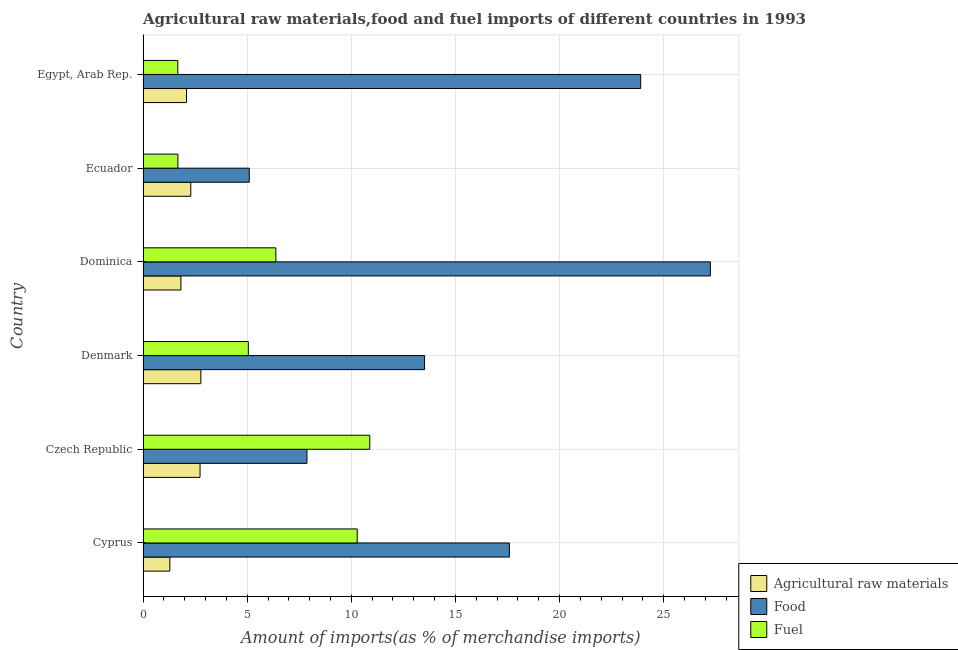How many different coloured bars are there?
Your answer should be compact. 3. How many groups of bars are there?
Ensure brevity in your answer.  6. Are the number of bars on each tick of the Y-axis equal?
Give a very brief answer. Yes. How many bars are there on the 5th tick from the top?
Your response must be concise. 3. How many bars are there on the 1st tick from the bottom?
Provide a short and direct response. 3. In how many cases, is the number of bars for a given country not equal to the number of legend labels?
Keep it short and to the point. 0. What is the percentage of fuel imports in Czech Republic?
Provide a succinct answer. 10.89. Across all countries, what is the maximum percentage of food imports?
Offer a very short reply. 27.24. Across all countries, what is the minimum percentage of fuel imports?
Ensure brevity in your answer.  1.67. In which country was the percentage of food imports maximum?
Provide a short and direct response. Dominica. In which country was the percentage of fuel imports minimum?
Your answer should be compact. Egypt, Arab Rep. What is the total percentage of raw materials imports in the graph?
Make the answer very short. 12.99. What is the difference between the percentage of fuel imports in Denmark and that in Dominica?
Offer a very short reply. -1.32. What is the difference between the percentage of food imports in Denmark and the percentage of raw materials imports in Dominica?
Give a very brief answer. 11.7. What is the average percentage of fuel imports per country?
Give a very brief answer. 5.99. What is the difference between the percentage of fuel imports and percentage of food imports in Egypt, Arab Rep.?
Your response must be concise. -22.23. In how many countries, is the percentage of raw materials imports greater than 7 %?
Make the answer very short. 0. What is the ratio of the percentage of fuel imports in Cyprus to that in Czech Republic?
Provide a short and direct response. 0.94. Is the difference between the percentage of fuel imports in Dominica and Ecuador greater than the difference between the percentage of food imports in Dominica and Ecuador?
Provide a succinct answer. No. What is the difference between the highest and the second highest percentage of fuel imports?
Your answer should be very brief. 0.6. What is the difference between the highest and the lowest percentage of fuel imports?
Provide a short and direct response. 9.22. What does the 2nd bar from the top in Ecuador represents?
Offer a terse response. Food. What does the 1st bar from the bottom in Egypt, Arab Rep. represents?
Keep it short and to the point. Agricultural raw materials. What is the difference between two consecutive major ticks on the X-axis?
Your answer should be very brief. 5. Are the values on the major ticks of X-axis written in scientific E-notation?
Offer a terse response. No. Does the graph contain any zero values?
Your response must be concise. No. Does the graph contain grids?
Your answer should be compact. Yes. Where does the legend appear in the graph?
Offer a very short reply. Bottom right. How many legend labels are there?
Ensure brevity in your answer.  3. What is the title of the graph?
Your response must be concise. Agricultural raw materials,food and fuel imports of different countries in 1993. Does "Gaseous fuel" appear as one of the legend labels in the graph?
Your answer should be very brief. No. What is the label or title of the X-axis?
Keep it short and to the point. Amount of imports(as % of merchandise imports). What is the label or title of the Y-axis?
Make the answer very short. Country. What is the Amount of imports(as % of merchandise imports) of Agricultural raw materials in Cyprus?
Provide a succinct answer. 1.29. What is the Amount of imports(as % of merchandise imports) of Food in Cyprus?
Make the answer very short. 17.59. What is the Amount of imports(as % of merchandise imports) in Fuel in Cyprus?
Your answer should be compact. 10.28. What is the Amount of imports(as % of merchandise imports) in Agricultural raw materials in Czech Republic?
Ensure brevity in your answer.  2.74. What is the Amount of imports(as % of merchandise imports) of Food in Czech Republic?
Give a very brief answer. 7.87. What is the Amount of imports(as % of merchandise imports) in Fuel in Czech Republic?
Keep it short and to the point. 10.89. What is the Amount of imports(as % of merchandise imports) in Agricultural raw materials in Denmark?
Offer a terse response. 2.78. What is the Amount of imports(as % of merchandise imports) of Food in Denmark?
Make the answer very short. 13.52. What is the Amount of imports(as % of merchandise imports) in Fuel in Denmark?
Provide a short and direct response. 5.06. What is the Amount of imports(as % of merchandise imports) of Agricultural raw materials in Dominica?
Make the answer very short. 1.82. What is the Amount of imports(as % of merchandise imports) of Food in Dominica?
Your answer should be compact. 27.24. What is the Amount of imports(as % of merchandise imports) in Fuel in Dominica?
Make the answer very short. 6.38. What is the Amount of imports(as % of merchandise imports) in Agricultural raw materials in Ecuador?
Make the answer very short. 2.29. What is the Amount of imports(as % of merchandise imports) of Food in Ecuador?
Make the answer very short. 5.1. What is the Amount of imports(as % of merchandise imports) in Fuel in Ecuador?
Your response must be concise. 1.67. What is the Amount of imports(as % of merchandise imports) in Agricultural raw materials in Egypt, Arab Rep.?
Your answer should be very brief. 2.09. What is the Amount of imports(as % of merchandise imports) in Food in Egypt, Arab Rep.?
Provide a short and direct response. 23.9. What is the Amount of imports(as % of merchandise imports) of Fuel in Egypt, Arab Rep.?
Offer a terse response. 1.67. Across all countries, what is the maximum Amount of imports(as % of merchandise imports) of Agricultural raw materials?
Your answer should be very brief. 2.78. Across all countries, what is the maximum Amount of imports(as % of merchandise imports) in Food?
Provide a succinct answer. 27.24. Across all countries, what is the maximum Amount of imports(as % of merchandise imports) in Fuel?
Provide a succinct answer. 10.89. Across all countries, what is the minimum Amount of imports(as % of merchandise imports) of Agricultural raw materials?
Provide a short and direct response. 1.29. Across all countries, what is the minimum Amount of imports(as % of merchandise imports) of Food?
Your response must be concise. 5.1. Across all countries, what is the minimum Amount of imports(as % of merchandise imports) of Fuel?
Keep it short and to the point. 1.67. What is the total Amount of imports(as % of merchandise imports) of Agricultural raw materials in the graph?
Your answer should be compact. 12.99. What is the total Amount of imports(as % of merchandise imports) of Food in the graph?
Your response must be concise. 95.22. What is the total Amount of imports(as % of merchandise imports) of Fuel in the graph?
Your response must be concise. 35.94. What is the difference between the Amount of imports(as % of merchandise imports) of Agricultural raw materials in Cyprus and that in Czech Republic?
Keep it short and to the point. -1.45. What is the difference between the Amount of imports(as % of merchandise imports) in Food in Cyprus and that in Czech Republic?
Give a very brief answer. 9.72. What is the difference between the Amount of imports(as % of merchandise imports) of Fuel in Cyprus and that in Czech Republic?
Offer a terse response. -0.6. What is the difference between the Amount of imports(as % of merchandise imports) of Agricultural raw materials in Cyprus and that in Denmark?
Keep it short and to the point. -1.49. What is the difference between the Amount of imports(as % of merchandise imports) of Food in Cyprus and that in Denmark?
Give a very brief answer. 4.07. What is the difference between the Amount of imports(as % of merchandise imports) of Fuel in Cyprus and that in Denmark?
Your answer should be very brief. 5.23. What is the difference between the Amount of imports(as % of merchandise imports) in Agricultural raw materials in Cyprus and that in Dominica?
Offer a terse response. -0.53. What is the difference between the Amount of imports(as % of merchandise imports) in Food in Cyprus and that in Dominica?
Offer a terse response. -9.65. What is the difference between the Amount of imports(as % of merchandise imports) of Fuel in Cyprus and that in Dominica?
Provide a succinct answer. 3.91. What is the difference between the Amount of imports(as % of merchandise imports) of Agricultural raw materials in Cyprus and that in Ecuador?
Offer a very short reply. -1.01. What is the difference between the Amount of imports(as % of merchandise imports) of Food in Cyprus and that in Ecuador?
Offer a terse response. 12.49. What is the difference between the Amount of imports(as % of merchandise imports) in Fuel in Cyprus and that in Ecuador?
Your response must be concise. 8.61. What is the difference between the Amount of imports(as % of merchandise imports) of Agricultural raw materials in Cyprus and that in Egypt, Arab Rep.?
Offer a terse response. -0.8. What is the difference between the Amount of imports(as % of merchandise imports) of Food in Cyprus and that in Egypt, Arab Rep.?
Offer a terse response. -6.31. What is the difference between the Amount of imports(as % of merchandise imports) in Fuel in Cyprus and that in Egypt, Arab Rep.?
Your response must be concise. 8.62. What is the difference between the Amount of imports(as % of merchandise imports) of Agricultural raw materials in Czech Republic and that in Denmark?
Your answer should be compact. -0.04. What is the difference between the Amount of imports(as % of merchandise imports) in Food in Czech Republic and that in Denmark?
Offer a terse response. -5.65. What is the difference between the Amount of imports(as % of merchandise imports) of Fuel in Czech Republic and that in Denmark?
Your answer should be compact. 5.83. What is the difference between the Amount of imports(as % of merchandise imports) of Agricultural raw materials in Czech Republic and that in Dominica?
Give a very brief answer. 0.92. What is the difference between the Amount of imports(as % of merchandise imports) in Food in Czech Republic and that in Dominica?
Your answer should be very brief. -19.37. What is the difference between the Amount of imports(as % of merchandise imports) of Fuel in Czech Republic and that in Dominica?
Ensure brevity in your answer.  4.51. What is the difference between the Amount of imports(as % of merchandise imports) of Agricultural raw materials in Czech Republic and that in Ecuador?
Offer a terse response. 0.45. What is the difference between the Amount of imports(as % of merchandise imports) in Food in Czech Republic and that in Ecuador?
Offer a very short reply. 2.77. What is the difference between the Amount of imports(as % of merchandise imports) of Fuel in Czech Republic and that in Ecuador?
Offer a very short reply. 9.21. What is the difference between the Amount of imports(as % of merchandise imports) of Agricultural raw materials in Czech Republic and that in Egypt, Arab Rep.?
Offer a very short reply. 0.65. What is the difference between the Amount of imports(as % of merchandise imports) of Food in Czech Republic and that in Egypt, Arab Rep.?
Your answer should be very brief. -16.03. What is the difference between the Amount of imports(as % of merchandise imports) in Fuel in Czech Republic and that in Egypt, Arab Rep.?
Offer a terse response. 9.22. What is the difference between the Amount of imports(as % of merchandise imports) in Agricultural raw materials in Denmark and that in Dominica?
Your answer should be compact. 0.96. What is the difference between the Amount of imports(as % of merchandise imports) in Food in Denmark and that in Dominica?
Provide a succinct answer. -13.73. What is the difference between the Amount of imports(as % of merchandise imports) in Fuel in Denmark and that in Dominica?
Provide a succinct answer. -1.32. What is the difference between the Amount of imports(as % of merchandise imports) in Agricultural raw materials in Denmark and that in Ecuador?
Your answer should be very brief. 0.48. What is the difference between the Amount of imports(as % of merchandise imports) of Food in Denmark and that in Ecuador?
Offer a very short reply. 8.42. What is the difference between the Amount of imports(as % of merchandise imports) in Fuel in Denmark and that in Ecuador?
Provide a succinct answer. 3.38. What is the difference between the Amount of imports(as % of merchandise imports) in Agricultural raw materials in Denmark and that in Egypt, Arab Rep.?
Provide a short and direct response. 0.69. What is the difference between the Amount of imports(as % of merchandise imports) in Food in Denmark and that in Egypt, Arab Rep.?
Offer a very short reply. -10.38. What is the difference between the Amount of imports(as % of merchandise imports) in Fuel in Denmark and that in Egypt, Arab Rep.?
Make the answer very short. 3.39. What is the difference between the Amount of imports(as % of merchandise imports) in Agricultural raw materials in Dominica and that in Ecuador?
Provide a short and direct response. -0.47. What is the difference between the Amount of imports(as % of merchandise imports) in Food in Dominica and that in Ecuador?
Give a very brief answer. 22.14. What is the difference between the Amount of imports(as % of merchandise imports) of Fuel in Dominica and that in Ecuador?
Ensure brevity in your answer.  4.7. What is the difference between the Amount of imports(as % of merchandise imports) in Agricultural raw materials in Dominica and that in Egypt, Arab Rep.?
Make the answer very short. -0.27. What is the difference between the Amount of imports(as % of merchandise imports) in Food in Dominica and that in Egypt, Arab Rep.?
Your answer should be very brief. 3.35. What is the difference between the Amount of imports(as % of merchandise imports) in Fuel in Dominica and that in Egypt, Arab Rep.?
Your response must be concise. 4.71. What is the difference between the Amount of imports(as % of merchandise imports) in Agricultural raw materials in Ecuador and that in Egypt, Arab Rep.?
Ensure brevity in your answer.  0.21. What is the difference between the Amount of imports(as % of merchandise imports) in Food in Ecuador and that in Egypt, Arab Rep.?
Give a very brief answer. -18.8. What is the difference between the Amount of imports(as % of merchandise imports) in Fuel in Ecuador and that in Egypt, Arab Rep.?
Give a very brief answer. 0. What is the difference between the Amount of imports(as % of merchandise imports) in Agricultural raw materials in Cyprus and the Amount of imports(as % of merchandise imports) in Food in Czech Republic?
Your response must be concise. -6.58. What is the difference between the Amount of imports(as % of merchandise imports) of Agricultural raw materials in Cyprus and the Amount of imports(as % of merchandise imports) of Fuel in Czech Republic?
Offer a terse response. -9.6. What is the difference between the Amount of imports(as % of merchandise imports) of Food in Cyprus and the Amount of imports(as % of merchandise imports) of Fuel in Czech Republic?
Make the answer very short. 6.71. What is the difference between the Amount of imports(as % of merchandise imports) of Agricultural raw materials in Cyprus and the Amount of imports(as % of merchandise imports) of Food in Denmark?
Provide a short and direct response. -12.23. What is the difference between the Amount of imports(as % of merchandise imports) of Agricultural raw materials in Cyprus and the Amount of imports(as % of merchandise imports) of Fuel in Denmark?
Provide a succinct answer. -3.77. What is the difference between the Amount of imports(as % of merchandise imports) in Food in Cyprus and the Amount of imports(as % of merchandise imports) in Fuel in Denmark?
Offer a terse response. 12.54. What is the difference between the Amount of imports(as % of merchandise imports) of Agricultural raw materials in Cyprus and the Amount of imports(as % of merchandise imports) of Food in Dominica?
Your response must be concise. -25.96. What is the difference between the Amount of imports(as % of merchandise imports) in Agricultural raw materials in Cyprus and the Amount of imports(as % of merchandise imports) in Fuel in Dominica?
Ensure brevity in your answer.  -5.09. What is the difference between the Amount of imports(as % of merchandise imports) in Food in Cyprus and the Amount of imports(as % of merchandise imports) in Fuel in Dominica?
Ensure brevity in your answer.  11.22. What is the difference between the Amount of imports(as % of merchandise imports) in Agricultural raw materials in Cyprus and the Amount of imports(as % of merchandise imports) in Food in Ecuador?
Make the answer very short. -3.81. What is the difference between the Amount of imports(as % of merchandise imports) of Agricultural raw materials in Cyprus and the Amount of imports(as % of merchandise imports) of Fuel in Ecuador?
Your response must be concise. -0.39. What is the difference between the Amount of imports(as % of merchandise imports) of Food in Cyprus and the Amount of imports(as % of merchandise imports) of Fuel in Ecuador?
Give a very brief answer. 15.92. What is the difference between the Amount of imports(as % of merchandise imports) of Agricultural raw materials in Cyprus and the Amount of imports(as % of merchandise imports) of Food in Egypt, Arab Rep.?
Your response must be concise. -22.61. What is the difference between the Amount of imports(as % of merchandise imports) of Agricultural raw materials in Cyprus and the Amount of imports(as % of merchandise imports) of Fuel in Egypt, Arab Rep.?
Offer a terse response. -0.38. What is the difference between the Amount of imports(as % of merchandise imports) of Food in Cyprus and the Amount of imports(as % of merchandise imports) of Fuel in Egypt, Arab Rep.?
Offer a very short reply. 15.92. What is the difference between the Amount of imports(as % of merchandise imports) in Agricultural raw materials in Czech Republic and the Amount of imports(as % of merchandise imports) in Food in Denmark?
Give a very brief answer. -10.78. What is the difference between the Amount of imports(as % of merchandise imports) of Agricultural raw materials in Czech Republic and the Amount of imports(as % of merchandise imports) of Fuel in Denmark?
Keep it short and to the point. -2.32. What is the difference between the Amount of imports(as % of merchandise imports) of Food in Czech Republic and the Amount of imports(as % of merchandise imports) of Fuel in Denmark?
Your response must be concise. 2.81. What is the difference between the Amount of imports(as % of merchandise imports) of Agricultural raw materials in Czech Republic and the Amount of imports(as % of merchandise imports) of Food in Dominica?
Your response must be concise. -24.51. What is the difference between the Amount of imports(as % of merchandise imports) in Agricultural raw materials in Czech Republic and the Amount of imports(as % of merchandise imports) in Fuel in Dominica?
Give a very brief answer. -3.64. What is the difference between the Amount of imports(as % of merchandise imports) in Food in Czech Republic and the Amount of imports(as % of merchandise imports) in Fuel in Dominica?
Provide a short and direct response. 1.49. What is the difference between the Amount of imports(as % of merchandise imports) of Agricultural raw materials in Czech Republic and the Amount of imports(as % of merchandise imports) of Food in Ecuador?
Keep it short and to the point. -2.36. What is the difference between the Amount of imports(as % of merchandise imports) in Agricultural raw materials in Czech Republic and the Amount of imports(as % of merchandise imports) in Fuel in Ecuador?
Offer a very short reply. 1.06. What is the difference between the Amount of imports(as % of merchandise imports) in Food in Czech Republic and the Amount of imports(as % of merchandise imports) in Fuel in Ecuador?
Keep it short and to the point. 6.2. What is the difference between the Amount of imports(as % of merchandise imports) in Agricultural raw materials in Czech Republic and the Amount of imports(as % of merchandise imports) in Food in Egypt, Arab Rep.?
Offer a very short reply. -21.16. What is the difference between the Amount of imports(as % of merchandise imports) of Agricultural raw materials in Czech Republic and the Amount of imports(as % of merchandise imports) of Fuel in Egypt, Arab Rep.?
Give a very brief answer. 1.07. What is the difference between the Amount of imports(as % of merchandise imports) in Food in Czech Republic and the Amount of imports(as % of merchandise imports) in Fuel in Egypt, Arab Rep.?
Your answer should be compact. 6.2. What is the difference between the Amount of imports(as % of merchandise imports) in Agricultural raw materials in Denmark and the Amount of imports(as % of merchandise imports) in Food in Dominica?
Make the answer very short. -24.47. What is the difference between the Amount of imports(as % of merchandise imports) of Agricultural raw materials in Denmark and the Amount of imports(as % of merchandise imports) of Fuel in Dominica?
Your response must be concise. -3.6. What is the difference between the Amount of imports(as % of merchandise imports) of Food in Denmark and the Amount of imports(as % of merchandise imports) of Fuel in Dominica?
Offer a terse response. 7.14. What is the difference between the Amount of imports(as % of merchandise imports) in Agricultural raw materials in Denmark and the Amount of imports(as % of merchandise imports) in Food in Ecuador?
Offer a very short reply. -2.33. What is the difference between the Amount of imports(as % of merchandise imports) of Agricultural raw materials in Denmark and the Amount of imports(as % of merchandise imports) of Fuel in Ecuador?
Offer a very short reply. 1.1. What is the difference between the Amount of imports(as % of merchandise imports) in Food in Denmark and the Amount of imports(as % of merchandise imports) in Fuel in Ecuador?
Keep it short and to the point. 11.85. What is the difference between the Amount of imports(as % of merchandise imports) of Agricultural raw materials in Denmark and the Amount of imports(as % of merchandise imports) of Food in Egypt, Arab Rep.?
Offer a terse response. -21.12. What is the difference between the Amount of imports(as % of merchandise imports) in Agricultural raw materials in Denmark and the Amount of imports(as % of merchandise imports) in Fuel in Egypt, Arab Rep.?
Your response must be concise. 1.11. What is the difference between the Amount of imports(as % of merchandise imports) of Food in Denmark and the Amount of imports(as % of merchandise imports) of Fuel in Egypt, Arab Rep.?
Keep it short and to the point. 11.85. What is the difference between the Amount of imports(as % of merchandise imports) in Agricultural raw materials in Dominica and the Amount of imports(as % of merchandise imports) in Food in Ecuador?
Make the answer very short. -3.28. What is the difference between the Amount of imports(as % of merchandise imports) of Agricultural raw materials in Dominica and the Amount of imports(as % of merchandise imports) of Fuel in Ecuador?
Offer a very short reply. 0.14. What is the difference between the Amount of imports(as % of merchandise imports) in Food in Dominica and the Amount of imports(as % of merchandise imports) in Fuel in Ecuador?
Your response must be concise. 25.57. What is the difference between the Amount of imports(as % of merchandise imports) in Agricultural raw materials in Dominica and the Amount of imports(as % of merchandise imports) in Food in Egypt, Arab Rep.?
Your answer should be compact. -22.08. What is the difference between the Amount of imports(as % of merchandise imports) of Agricultural raw materials in Dominica and the Amount of imports(as % of merchandise imports) of Fuel in Egypt, Arab Rep.?
Your answer should be very brief. 0.15. What is the difference between the Amount of imports(as % of merchandise imports) of Food in Dominica and the Amount of imports(as % of merchandise imports) of Fuel in Egypt, Arab Rep.?
Your response must be concise. 25.58. What is the difference between the Amount of imports(as % of merchandise imports) of Agricultural raw materials in Ecuador and the Amount of imports(as % of merchandise imports) of Food in Egypt, Arab Rep.?
Make the answer very short. -21.61. What is the difference between the Amount of imports(as % of merchandise imports) in Agricultural raw materials in Ecuador and the Amount of imports(as % of merchandise imports) in Fuel in Egypt, Arab Rep.?
Your answer should be very brief. 0.62. What is the difference between the Amount of imports(as % of merchandise imports) in Food in Ecuador and the Amount of imports(as % of merchandise imports) in Fuel in Egypt, Arab Rep.?
Your response must be concise. 3.43. What is the average Amount of imports(as % of merchandise imports) of Agricultural raw materials per country?
Your response must be concise. 2.17. What is the average Amount of imports(as % of merchandise imports) in Food per country?
Your response must be concise. 15.87. What is the average Amount of imports(as % of merchandise imports) in Fuel per country?
Keep it short and to the point. 5.99. What is the difference between the Amount of imports(as % of merchandise imports) of Agricultural raw materials and Amount of imports(as % of merchandise imports) of Food in Cyprus?
Your answer should be very brief. -16.31. What is the difference between the Amount of imports(as % of merchandise imports) of Agricultural raw materials and Amount of imports(as % of merchandise imports) of Fuel in Cyprus?
Ensure brevity in your answer.  -9. What is the difference between the Amount of imports(as % of merchandise imports) in Food and Amount of imports(as % of merchandise imports) in Fuel in Cyprus?
Offer a terse response. 7.31. What is the difference between the Amount of imports(as % of merchandise imports) in Agricultural raw materials and Amount of imports(as % of merchandise imports) in Food in Czech Republic?
Provide a succinct answer. -5.13. What is the difference between the Amount of imports(as % of merchandise imports) in Agricultural raw materials and Amount of imports(as % of merchandise imports) in Fuel in Czech Republic?
Offer a terse response. -8.15. What is the difference between the Amount of imports(as % of merchandise imports) in Food and Amount of imports(as % of merchandise imports) in Fuel in Czech Republic?
Your answer should be very brief. -3.02. What is the difference between the Amount of imports(as % of merchandise imports) of Agricultural raw materials and Amount of imports(as % of merchandise imports) of Food in Denmark?
Keep it short and to the point. -10.74. What is the difference between the Amount of imports(as % of merchandise imports) of Agricultural raw materials and Amount of imports(as % of merchandise imports) of Fuel in Denmark?
Your answer should be very brief. -2.28. What is the difference between the Amount of imports(as % of merchandise imports) of Food and Amount of imports(as % of merchandise imports) of Fuel in Denmark?
Offer a very short reply. 8.46. What is the difference between the Amount of imports(as % of merchandise imports) of Agricultural raw materials and Amount of imports(as % of merchandise imports) of Food in Dominica?
Your answer should be compact. -25.43. What is the difference between the Amount of imports(as % of merchandise imports) of Agricultural raw materials and Amount of imports(as % of merchandise imports) of Fuel in Dominica?
Your answer should be very brief. -4.56. What is the difference between the Amount of imports(as % of merchandise imports) of Food and Amount of imports(as % of merchandise imports) of Fuel in Dominica?
Give a very brief answer. 20.87. What is the difference between the Amount of imports(as % of merchandise imports) of Agricultural raw materials and Amount of imports(as % of merchandise imports) of Food in Ecuador?
Ensure brevity in your answer.  -2.81. What is the difference between the Amount of imports(as % of merchandise imports) in Agricultural raw materials and Amount of imports(as % of merchandise imports) in Fuel in Ecuador?
Ensure brevity in your answer.  0.62. What is the difference between the Amount of imports(as % of merchandise imports) in Food and Amount of imports(as % of merchandise imports) in Fuel in Ecuador?
Offer a terse response. 3.43. What is the difference between the Amount of imports(as % of merchandise imports) of Agricultural raw materials and Amount of imports(as % of merchandise imports) of Food in Egypt, Arab Rep.?
Ensure brevity in your answer.  -21.81. What is the difference between the Amount of imports(as % of merchandise imports) in Agricultural raw materials and Amount of imports(as % of merchandise imports) in Fuel in Egypt, Arab Rep.?
Provide a short and direct response. 0.42. What is the difference between the Amount of imports(as % of merchandise imports) of Food and Amount of imports(as % of merchandise imports) of Fuel in Egypt, Arab Rep.?
Your answer should be very brief. 22.23. What is the ratio of the Amount of imports(as % of merchandise imports) of Agricultural raw materials in Cyprus to that in Czech Republic?
Offer a very short reply. 0.47. What is the ratio of the Amount of imports(as % of merchandise imports) of Food in Cyprus to that in Czech Republic?
Keep it short and to the point. 2.24. What is the ratio of the Amount of imports(as % of merchandise imports) of Fuel in Cyprus to that in Czech Republic?
Offer a terse response. 0.94. What is the ratio of the Amount of imports(as % of merchandise imports) in Agricultural raw materials in Cyprus to that in Denmark?
Make the answer very short. 0.46. What is the ratio of the Amount of imports(as % of merchandise imports) of Food in Cyprus to that in Denmark?
Ensure brevity in your answer.  1.3. What is the ratio of the Amount of imports(as % of merchandise imports) of Fuel in Cyprus to that in Denmark?
Ensure brevity in your answer.  2.03. What is the ratio of the Amount of imports(as % of merchandise imports) of Agricultural raw materials in Cyprus to that in Dominica?
Make the answer very short. 0.71. What is the ratio of the Amount of imports(as % of merchandise imports) in Food in Cyprus to that in Dominica?
Your answer should be compact. 0.65. What is the ratio of the Amount of imports(as % of merchandise imports) in Fuel in Cyprus to that in Dominica?
Your answer should be compact. 1.61. What is the ratio of the Amount of imports(as % of merchandise imports) of Agricultural raw materials in Cyprus to that in Ecuador?
Your answer should be compact. 0.56. What is the ratio of the Amount of imports(as % of merchandise imports) of Food in Cyprus to that in Ecuador?
Provide a succinct answer. 3.45. What is the ratio of the Amount of imports(as % of merchandise imports) in Fuel in Cyprus to that in Ecuador?
Your response must be concise. 6.15. What is the ratio of the Amount of imports(as % of merchandise imports) of Agricultural raw materials in Cyprus to that in Egypt, Arab Rep.?
Make the answer very short. 0.62. What is the ratio of the Amount of imports(as % of merchandise imports) of Food in Cyprus to that in Egypt, Arab Rep.?
Offer a very short reply. 0.74. What is the ratio of the Amount of imports(as % of merchandise imports) of Fuel in Cyprus to that in Egypt, Arab Rep.?
Offer a very short reply. 6.16. What is the ratio of the Amount of imports(as % of merchandise imports) in Food in Czech Republic to that in Denmark?
Provide a succinct answer. 0.58. What is the ratio of the Amount of imports(as % of merchandise imports) of Fuel in Czech Republic to that in Denmark?
Give a very brief answer. 2.15. What is the ratio of the Amount of imports(as % of merchandise imports) in Agricultural raw materials in Czech Republic to that in Dominica?
Your answer should be compact. 1.51. What is the ratio of the Amount of imports(as % of merchandise imports) in Food in Czech Republic to that in Dominica?
Ensure brevity in your answer.  0.29. What is the ratio of the Amount of imports(as % of merchandise imports) in Fuel in Czech Republic to that in Dominica?
Ensure brevity in your answer.  1.71. What is the ratio of the Amount of imports(as % of merchandise imports) in Agricultural raw materials in Czech Republic to that in Ecuador?
Ensure brevity in your answer.  1.19. What is the ratio of the Amount of imports(as % of merchandise imports) of Food in Czech Republic to that in Ecuador?
Keep it short and to the point. 1.54. What is the ratio of the Amount of imports(as % of merchandise imports) of Fuel in Czech Republic to that in Ecuador?
Provide a succinct answer. 6.51. What is the ratio of the Amount of imports(as % of merchandise imports) of Agricultural raw materials in Czech Republic to that in Egypt, Arab Rep.?
Your response must be concise. 1.31. What is the ratio of the Amount of imports(as % of merchandise imports) in Food in Czech Republic to that in Egypt, Arab Rep.?
Make the answer very short. 0.33. What is the ratio of the Amount of imports(as % of merchandise imports) in Fuel in Czech Republic to that in Egypt, Arab Rep.?
Provide a short and direct response. 6.53. What is the ratio of the Amount of imports(as % of merchandise imports) of Agricultural raw materials in Denmark to that in Dominica?
Your answer should be compact. 1.53. What is the ratio of the Amount of imports(as % of merchandise imports) in Food in Denmark to that in Dominica?
Your response must be concise. 0.5. What is the ratio of the Amount of imports(as % of merchandise imports) in Fuel in Denmark to that in Dominica?
Your response must be concise. 0.79. What is the ratio of the Amount of imports(as % of merchandise imports) in Agricultural raw materials in Denmark to that in Ecuador?
Keep it short and to the point. 1.21. What is the ratio of the Amount of imports(as % of merchandise imports) in Food in Denmark to that in Ecuador?
Provide a short and direct response. 2.65. What is the ratio of the Amount of imports(as % of merchandise imports) in Fuel in Denmark to that in Ecuador?
Keep it short and to the point. 3.02. What is the ratio of the Amount of imports(as % of merchandise imports) in Agricultural raw materials in Denmark to that in Egypt, Arab Rep.?
Keep it short and to the point. 1.33. What is the ratio of the Amount of imports(as % of merchandise imports) of Food in Denmark to that in Egypt, Arab Rep.?
Your answer should be compact. 0.57. What is the ratio of the Amount of imports(as % of merchandise imports) in Fuel in Denmark to that in Egypt, Arab Rep.?
Make the answer very short. 3.03. What is the ratio of the Amount of imports(as % of merchandise imports) of Agricultural raw materials in Dominica to that in Ecuador?
Keep it short and to the point. 0.79. What is the ratio of the Amount of imports(as % of merchandise imports) of Food in Dominica to that in Ecuador?
Your answer should be compact. 5.34. What is the ratio of the Amount of imports(as % of merchandise imports) of Fuel in Dominica to that in Ecuador?
Give a very brief answer. 3.81. What is the ratio of the Amount of imports(as % of merchandise imports) of Agricultural raw materials in Dominica to that in Egypt, Arab Rep.?
Keep it short and to the point. 0.87. What is the ratio of the Amount of imports(as % of merchandise imports) in Food in Dominica to that in Egypt, Arab Rep.?
Keep it short and to the point. 1.14. What is the ratio of the Amount of imports(as % of merchandise imports) in Fuel in Dominica to that in Egypt, Arab Rep.?
Make the answer very short. 3.82. What is the ratio of the Amount of imports(as % of merchandise imports) in Agricultural raw materials in Ecuador to that in Egypt, Arab Rep.?
Provide a short and direct response. 1.1. What is the ratio of the Amount of imports(as % of merchandise imports) of Food in Ecuador to that in Egypt, Arab Rep.?
Your answer should be compact. 0.21. What is the ratio of the Amount of imports(as % of merchandise imports) in Fuel in Ecuador to that in Egypt, Arab Rep.?
Ensure brevity in your answer.  1. What is the difference between the highest and the second highest Amount of imports(as % of merchandise imports) of Agricultural raw materials?
Give a very brief answer. 0.04. What is the difference between the highest and the second highest Amount of imports(as % of merchandise imports) of Food?
Your answer should be very brief. 3.35. What is the difference between the highest and the second highest Amount of imports(as % of merchandise imports) of Fuel?
Your answer should be compact. 0.6. What is the difference between the highest and the lowest Amount of imports(as % of merchandise imports) of Agricultural raw materials?
Keep it short and to the point. 1.49. What is the difference between the highest and the lowest Amount of imports(as % of merchandise imports) in Food?
Your answer should be very brief. 22.14. What is the difference between the highest and the lowest Amount of imports(as % of merchandise imports) of Fuel?
Keep it short and to the point. 9.22. 